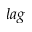Convert formula to latex. <formula><loc_0><loc_0><loc_500><loc_500>l a g</formula> 